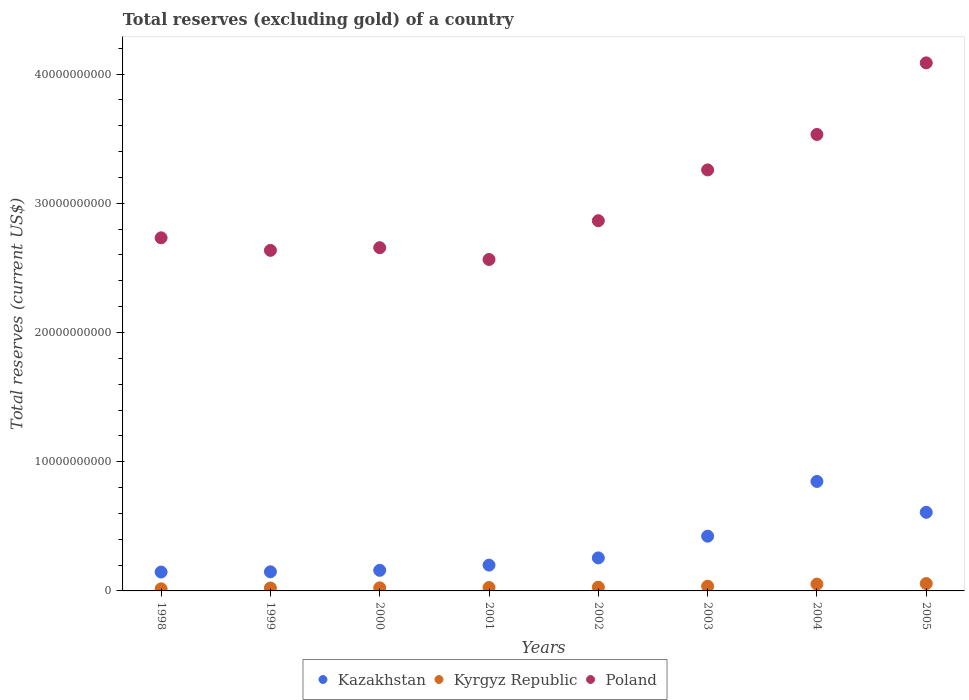How many different coloured dotlines are there?
Make the answer very short. 3. What is the total reserves (excluding gold) in Kazakhstan in 2001?
Ensure brevity in your answer.  2.00e+09. Across all years, what is the maximum total reserves (excluding gold) in Kazakhstan?
Ensure brevity in your answer.  8.47e+09. Across all years, what is the minimum total reserves (excluding gold) in Poland?
Make the answer very short. 2.56e+1. In which year was the total reserves (excluding gold) in Kazakhstan minimum?
Your response must be concise. 1998. What is the total total reserves (excluding gold) in Kyrgyz Republic in the graph?
Provide a short and direct response. 2.65e+09. What is the difference between the total reserves (excluding gold) in Kazakhstan in 2004 and that in 2005?
Offer a terse response. 2.39e+09. What is the difference between the total reserves (excluding gold) in Kazakhstan in 2005 and the total reserves (excluding gold) in Kyrgyz Republic in 2000?
Your answer should be very brief. 5.85e+09. What is the average total reserves (excluding gold) in Kazakhstan per year?
Ensure brevity in your answer.  3.49e+09. In the year 2004, what is the difference between the total reserves (excluding gold) in Kazakhstan and total reserves (excluding gold) in Poland?
Offer a terse response. -2.69e+1. In how many years, is the total reserves (excluding gold) in Poland greater than 24000000000 US$?
Ensure brevity in your answer.  8. What is the ratio of the total reserves (excluding gold) in Kazakhstan in 2000 to that in 2004?
Keep it short and to the point. 0.19. Is the difference between the total reserves (excluding gold) in Kazakhstan in 1998 and 1999 greater than the difference between the total reserves (excluding gold) in Poland in 1998 and 1999?
Provide a succinct answer. No. What is the difference between the highest and the second highest total reserves (excluding gold) in Poland?
Offer a terse response. 5.54e+09. What is the difference between the highest and the lowest total reserves (excluding gold) in Kyrgyz Republic?
Your answer should be very brief. 4.06e+08. Is it the case that in every year, the sum of the total reserves (excluding gold) in Poland and total reserves (excluding gold) in Kazakhstan  is greater than the total reserves (excluding gold) in Kyrgyz Republic?
Provide a short and direct response. Yes. Is the total reserves (excluding gold) in Kazakhstan strictly greater than the total reserves (excluding gold) in Poland over the years?
Your answer should be compact. No. How many dotlines are there?
Provide a succinct answer. 3. How many years are there in the graph?
Provide a short and direct response. 8. Are the values on the major ticks of Y-axis written in scientific E-notation?
Provide a succinct answer. No. Does the graph contain any zero values?
Provide a short and direct response. No. Does the graph contain grids?
Give a very brief answer. No. Where does the legend appear in the graph?
Your response must be concise. Bottom center. What is the title of the graph?
Provide a succinct answer. Total reserves (excluding gold) of a country. Does "Cayman Islands" appear as one of the legend labels in the graph?
Make the answer very short. No. What is the label or title of the X-axis?
Make the answer very short. Years. What is the label or title of the Y-axis?
Your answer should be very brief. Total reserves (current US$). What is the Total reserves (current US$) in Kazakhstan in 1998?
Offer a terse response. 1.46e+09. What is the Total reserves (current US$) of Kyrgyz Republic in 1998?
Provide a short and direct response. 1.64e+08. What is the Total reserves (current US$) of Poland in 1998?
Your response must be concise. 2.73e+1. What is the Total reserves (current US$) of Kazakhstan in 1999?
Provide a short and direct response. 1.48e+09. What is the Total reserves (current US$) in Kyrgyz Republic in 1999?
Your response must be concise. 2.30e+08. What is the Total reserves (current US$) in Poland in 1999?
Offer a very short reply. 2.64e+1. What is the Total reserves (current US$) in Kazakhstan in 2000?
Make the answer very short. 1.59e+09. What is the Total reserves (current US$) of Kyrgyz Republic in 2000?
Provide a succinct answer. 2.39e+08. What is the Total reserves (current US$) in Poland in 2000?
Your answer should be very brief. 2.66e+1. What is the Total reserves (current US$) of Kazakhstan in 2001?
Your answer should be compact. 2.00e+09. What is the Total reserves (current US$) of Kyrgyz Republic in 2001?
Ensure brevity in your answer.  2.64e+08. What is the Total reserves (current US$) of Poland in 2001?
Offer a terse response. 2.56e+1. What is the Total reserves (current US$) in Kazakhstan in 2002?
Your response must be concise. 2.56e+09. What is the Total reserves (current US$) of Kyrgyz Republic in 2002?
Make the answer very short. 2.89e+08. What is the Total reserves (current US$) in Poland in 2002?
Ensure brevity in your answer.  2.86e+1. What is the Total reserves (current US$) in Kazakhstan in 2003?
Give a very brief answer. 4.24e+09. What is the Total reserves (current US$) of Kyrgyz Republic in 2003?
Provide a short and direct response. 3.65e+08. What is the Total reserves (current US$) in Poland in 2003?
Give a very brief answer. 3.26e+1. What is the Total reserves (current US$) in Kazakhstan in 2004?
Offer a very short reply. 8.47e+09. What is the Total reserves (current US$) in Kyrgyz Republic in 2004?
Your response must be concise. 5.28e+08. What is the Total reserves (current US$) of Poland in 2004?
Offer a very short reply. 3.53e+1. What is the Total reserves (current US$) in Kazakhstan in 2005?
Your answer should be compact. 6.08e+09. What is the Total reserves (current US$) of Kyrgyz Republic in 2005?
Ensure brevity in your answer.  5.70e+08. What is the Total reserves (current US$) of Poland in 2005?
Give a very brief answer. 4.09e+1. Across all years, what is the maximum Total reserves (current US$) in Kazakhstan?
Your answer should be compact. 8.47e+09. Across all years, what is the maximum Total reserves (current US$) in Kyrgyz Republic?
Your response must be concise. 5.70e+08. Across all years, what is the maximum Total reserves (current US$) in Poland?
Ensure brevity in your answer.  4.09e+1. Across all years, what is the minimum Total reserves (current US$) in Kazakhstan?
Provide a succinct answer. 1.46e+09. Across all years, what is the minimum Total reserves (current US$) in Kyrgyz Republic?
Your answer should be compact. 1.64e+08. Across all years, what is the minimum Total reserves (current US$) of Poland?
Your response must be concise. 2.56e+1. What is the total Total reserves (current US$) in Kazakhstan in the graph?
Provide a succinct answer. 2.79e+1. What is the total Total reserves (current US$) in Kyrgyz Republic in the graph?
Ensure brevity in your answer.  2.65e+09. What is the total Total reserves (current US$) of Poland in the graph?
Provide a succinct answer. 2.43e+11. What is the difference between the Total reserves (current US$) of Kazakhstan in 1998 and that in 1999?
Your answer should be compact. -1.80e+07. What is the difference between the Total reserves (current US$) of Kyrgyz Republic in 1998 and that in 1999?
Keep it short and to the point. -6.59e+07. What is the difference between the Total reserves (current US$) of Poland in 1998 and that in 1999?
Ensure brevity in your answer.  9.70e+08. What is the difference between the Total reserves (current US$) of Kazakhstan in 1998 and that in 2000?
Ensure brevity in your answer.  -1.33e+08. What is the difference between the Total reserves (current US$) of Kyrgyz Republic in 1998 and that in 2000?
Your response must be concise. -7.53e+07. What is the difference between the Total reserves (current US$) of Poland in 1998 and that in 2000?
Your answer should be compact. 7.63e+08. What is the difference between the Total reserves (current US$) in Kazakhstan in 1998 and that in 2001?
Your answer should be compact. -5.36e+08. What is the difference between the Total reserves (current US$) of Kyrgyz Republic in 1998 and that in 2001?
Keep it short and to the point. -9.98e+07. What is the difference between the Total reserves (current US$) in Poland in 1998 and that in 2001?
Offer a terse response. 1.68e+09. What is the difference between the Total reserves (current US$) of Kazakhstan in 1998 and that in 2002?
Your answer should be compact. -1.09e+09. What is the difference between the Total reserves (current US$) in Kyrgyz Republic in 1998 and that in 2002?
Your answer should be compact. -1.25e+08. What is the difference between the Total reserves (current US$) of Poland in 1998 and that in 2002?
Your response must be concise. -1.32e+09. What is the difference between the Total reserves (current US$) of Kazakhstan in 1998 and that in 2003?
Ensure brevity in your answer.  -2.77e+09. What is the difference between the Total reserves (current US$) in Kyrgyz Republic in 1998 and that in 2003?
Offer a very short reply. -2.01e+08. What is the difference between the Total reserves (current US$) in Poland in 1998 and that in 2003?
Keep it short and to the point. -5.25e+09. What is the difference between the Total reserves (current US$) in Kazakhstan in 1998 and that in 2004?
Provide a short and direct response. -7.01e+09. What is the difference between the Total reserves (current US$) of Kyrgyz Republic in 1998 and that in 2004?
Your response must be concise. -3.64e+08. What is the difference between the Total reserves (current US$) of Poland in 1998 and that in 2004?
Provide a succinct answer. -8.00e+09. What is the difference between the Total reserves (current US$) in Kazakhstan in 1998 and that in 2005?
Your response must be concise. -4.62e+09. What is the difference between the Total reserves (current US$) of Kyrgyz Republic in 1998 and that in 2005?
Ensure brevity in your answer.  -4.06e+08. What is the difference between the Total reserves (current US$) in Poland in 1998 and that in 2005?
Offer a terse response. -1.35e+1. What is the difference between the Total reserves (current US$) of Kazakhstan in 1999 and that in 2000?
Your response must be concise. -1.15e+08. What is the difference between the Total reserves (current US$) of Kyrgyz Republic in 1999 and that in 2000?
Offer a terse response. -9.36e+06. What is the difference between the Total reserves (current US$) of Poland in 1999 and that in 2000?
Make the answer very short. -2.07e+08. What is the difference between the Total reserves (current US$) in Kazakhstan in 1999 and that in 2001?
Your response must be concise. -5.18e+08. What is the difference between the Total reserves (current US$) of Kyrgyz Republic in 1999 and that in 2001?
Your response must be concise. -3.38e+07. What is the difference between the Total reserves (current US$) in Poland in 1999 and that in 2001?
Your response must be concise. 7.06e+08. What is the difference between the Total reserves (current US$) of Kazakhstan in 1999 and that in 2002?
Keep it short and to the point. -1.08e+09. What is the difference between the Total reserves (current US$) of Kyrgyz Republic in 1999 and that in 2002?
Offer a very short reply. -5.92e+07. What is the difference between the Total reserves (current US$) of Poland in 1999 and that in 2002?
Your response must be concise. -2.30e+09. What is the difference between the Total reserves (current US$) of Kazakhstan in 1999 and that in 2003?
Offer a very short reply. -2.76e+09. What is the difference between the Total reserves (current US$) of Kyrgyz Republic in 1999 and that in 2003?
Give a very brief answer. -1.35e+08. What is the difference between the Total reserves (current US$) in Poland in 1999 and that in 2003?
Make the answer very short. -6.22e+09. What is the difference between the Total reserves (current US$) in Kazakhstan in 1999 and that in 2004?
Make the answer very short. -6.99e+09. What is the difference between the Total reserves (current US$) in Kyrgyz Republic in 1999 and that in 2004?
Your response must be concise. -2.98e+08. What is the difference between the Total reserves (current US$) in Poland in 1999 and that in 2004?
Offer a terse response. -8.97e+09. What is the difference between the Total reserves (current US$) in Kazakhstan in 1999 and that in 2005?
Ensure brevity in your answer.  -4.60e+09. What is the difference between the Total reserves (current US$) in Kyrgyz Republic in 1999 and that in 2005?
Make the answer very short. -3.40e+08. What is the difference between the Total reserves (current US$) in Poland in 1999 and that in 2005?
Provide a short and direct response. -1.45e+1. What is the difference between the Total reserves (current US$) in Kazakhstan in 2000 and that in 2001?
Give a very brief answer. -4.03e+08. What is the difference between the Total reserves (current US$) of Kyrgyz Republic in 2000 and that in 2001?
Your response must be concise. -2.45e+07. What is the difference between the Total reserves (current US$) in Poland in 2000 and that in 2001?
Offer a very short reply. 9.14e+08. What is the difference between the Total reserves (current US$) of Kazakhstan in 2000 and that in 2002?
Offer a very short reply. -9.61e+08. What is the difference between the Total reserves (current US$) in Kyrgyz Republic in 2000 and that in 2002?
Ensure brevity in your answer.  -4.98e+07. What is the difference between the Total reserves (current US$) in Poland in 2000 and that in 2002?
Give a very brief answer. -2.09e+09. What is the difference between the Total reserves (current US$) of Kazakhstan in 2000 and that in 2003?
Your answer should be compact. -2.64e+09. What is the difference between the Total reserves (current US$) of Kyrgyz Republic in 2000 and that in 2003?
Offer a terse response. -1.26e+08. What is the difference between the Total reserves (current US$) in Poland in 2000 and that in 2003?
Provide a succinct answer. -6.02e+09. What is the difference between the Total reserves (current US$) in Kazakhstan in 2000 and that in 2004?
Your response must be concise. -6.88e+09. What is the difference between the Total reserves (current US$) in Kyrgyz Republic in 2000 and that in 2004?
Provide a succinct answer. -2.89e+08. What is the difference between the Total reserves (current US$) of Poland in 2000 and that in 2004?
Offer a very short reply. -8.76e+09. What is the difference between the Total reserves (current US$) in Kazakhstan in 2000 and that in 2005?
Offer a very short reply. -4.49e+09. What is the difference between the Total reserves (current US$) of Kyrgyz Republic in 2000 and that in 2005?
Offer a very short reply. -3.31e+08. What is the difference between the Total reserves (current US$) of Poland in 2000 and that in 2005?
Offer a terse response. -1.43e+1. What is the difference between the Total reserves (current US$) in Kazakhstan in 2001 and that in 2002?
Your answer should be compact. -5.58e+08. What is the difference between the Total reserves (current US$) of Kyrgyz Republic in 2001 and that in 2002?
Your response must be concise. -2.53e+07. What is the difference between the Total reserves (current US$) in Poland in 2001 and that in 2002?
Offer a very short reply. -3.00e+09. What is the difference between the Total reserves (current US$) of Kazakhstan in 2001 and that in 2003?
Offer a terse response. -2.24e+09. What is the difference between the Total reserves (current US$) of Kyrgyz Republic in 2001 and that in 2003?
Your answer should be compact. -1.01e+08. What is the difference between the Total reserves (current US$) of Poland in 2001 and that in 2003?
Keep it short and to the point. -6.93e+09. What is the difference between the Total reserves (current US$) of Kazakhstan in 2001 and that in 2004?
Your answer should be compact. -6.48e+09. What is the difference between the Total reserves (current US$) of Kyrgyz Republic in 2001 and that in 2004?
Provide a short and direct response. -2.65e+08. What is the difference between the Total reserves (current US$) in Poland in 2001 and that in 2004?
Give a very brief answer. -9.68e+09. What is the difference between the Total reserves (current US$) in Kazakhstan in 2001 and that in 2005?
Make the answer very short. -4.09e+09. What is the difference between the Total reserves (current US$) of Kyrgyz Republic in 2001 and that in 2005?
Keep it short and to the point. -3.06e+08. What is the difference between the Total reserves (current US$) in Poland in 2001 and that in 2005?
Your answer should be very brief. -1.52e+1. What is the difference between the Total reserves (current US$) in Kazakhstan in 2002 and that in 2003?
Offer a very short reply. -1.68e+09. What is the difference between the Total reserves (current US$) in Kyrgyz Republic in 2002 and that in 2003?
Provide a succinct answer. -7.57e+07. What is the difference between the Total reserves (current US$) in Poland in 2002 and that in 2003?
Offer a terse response. -3.93e+09. What is the difference between the Total reserves (current US$) of Kazakhstan in 2002 and that in 2004?
Make the answer very short. -5.92e+09. What is the difference between the Total reserves (current US$) of Kyrgyz Republic in 2002 and that in 2004?
Make the answer very short. -2.39e+08. What is the difference between the Total reserves (current US$) of Poland in 2002 and that in 2004?
Provide a succinct answer. -6.67e+09. What is the difference between the Total reserves (current US$) in Kazakhstan in 2002 and that in 2005?
Give a very brief answer. -3.53e+09. What is the difference between the Total reserves (current US$) in Kyrgyz Republic in 2002 and that in 2005?
Your answer should be compact. -2.81e+08. What is the difference between the Total reserves (current US$) in Poland in 2002 and that in 2005?
Provide a short and direct response. -1.22e+1. What is the difference between the Total reserves (current US$) of Kazakhstan in 2003 and that in 2004?
Ensure brevity in your answer.  -4.24e+09. What is the difference between the Total reserves (current US$) of Kyrgyz Republic in 2003 and that in 2004?
Keep it short and to the point. -1.64e+08. What is the difference between the Total reserves (current US$) of Poland in 2003 and that in 2004?
Make the answer very short. -2.74e+09. What is the difference between the Total reserves (current US$) of Kazakhstan in 2003 and that in 2005?
Offer a very short reply. -1.85e+09. What is the difference between the Total reserves (current US$) of Kyrgyz Republic in 2003 and that in 2005?
Make the answer very short. -2.05e+08. What is the difference between the Total reserves (current US$) of Poland in 2003 and that in 2005?
Provide a short and direct response. -8.28e+09. What is the difference between the Total reserves (current US$) in Kazakhstan in 2004 and that in 2005?
Your response must be concise. 2.39e+09. What is the difference between the Total reserves (current US$) in Kyrgyz Republic in 2004 and that in 2005?
Provide a succinct answer. -4.16e+07. What is the difference between the Total reserves (current US$) of Poland in 2004 and that in 2005?
Provide a succinct answer. -5.54e+09. What is the difference between the Total reserves (current US$) of Kazakhstan in 1998 and the Total reserves (current US$) of Kyrgyz Republic in 1999?
Your answer should be very brief. 1.23e+09. What is the difference between the Total reserves (current US$) in Kazakhstan in 1998 and the Total reserves (current US$) in Poland in 1999?
Ensure brevity in your answer.  -2.49e+1. What is the difference between the Total reserves (current US$) in Kyrgyz Republic in 1998 and the Total reserves (current US$) in Poland in 1999?
Your answer should be very brief. -2.62e+1. What is the difference between the Total reserves (current US$) in Kazakhstan in 1998 and the Total reserves (current US$) in Kyrgyz Republic in 2000?
Give a very brief answer. 1.22e+09. What is the difference between the Total reserves (current US$) in Kazakhstan in 1998 and the Total reserves (current US$) in Poland in 2000?
Your answer should be very brief. -2.51e+1. What is the difference between the Total reserves (current US$) of Kyrgyz Republic in 1998 and the Total reserves (current US$) of Poland in 2000?
Give a very brief answer. -2.64e+1. What is the difference between the Total reserves (current US$) of Kazakhstan in 1998 and the Total reserves (current US$) of Kyrgyz Republic in 2001?
Provide a succinct answer. 1.20e+09. What is the difference between the Total reserves (current US$) of Kazakhstan in 1998 and the Total reserves (current US$) of Poland in 2001?
Provide a succinct answer. -2.42e+1. What is the difference between the Total reserves (current US$) in Kyrgyz Republic in 1998 and the Total reserves (current US$) in Poland in 2001?
Provide a succinct answer. -2.55e+1. What is the difference between the Total reserves (current US$) of Kazakhstan in 1998 and the Total reserves (current US$) of Kyrgyz Republic in 2002?
Your answer should be very brief. 1.17e+09. What is the difference between the Total reserves (current US$) of Kazakhstan in 1998 and the Total reserves (current US$) of Poland in 2002?
Your answer should be compact. -2.72e+1. What is the difference between the Total reserves (current US$) of Kyrgyz Republic in 1998 and the Total reserves (current US$) of Poland in 2002?
Ensure brevity in your answer.  -2.85e+1. What is the difference between the Total reserves (current US$) in Kazakhstan in 1998 and the Total reserves (current US$) in Kyrgyz Republic in 2003?
Your answer should be compact. 1.10e+09. What is the difference between the Total reserves (current US$) of Kazakhstan in 1998 and the Total reserves (current US$) of Poland in 2003?
Provide a short and direct response. -3.11e+1. What is the difference between the Total reserves (current US$) in Kyrgyz Republic in 1998 and the Total reserves (current US$) in Poland in 2003?
Keep it short and to the point. -3.24e+1. What is the difference between the Total reserves (current US$) in Kazakhstan in 1998 and the Total reserves (current US$) in Kyrgyz Republic in 2004?
Offer a terse response. 9.33e+08. What is the difference between the Total reserves (current US$) of Kazakhstan in 1998 and the Total reserves (current US$) of Poland in 2004?
Give a very brief answer. -3.39e+1. What is the difference between the Total reserves (current US$) of Kyrgyz Republic in 1998 and the Total reserves (current US$) of Poland in 2004?
Your answer should be compact. -3.52e+1. What is the difference between the Total reserves (current US$) in Kazakhstan in 1998 and the Total reserves (current US$) in Kyrgyz Republic in 2005?
Your answer should be very brief. 8.91e+08. What is the difference between the Total reserves (current US$) of Kazakhstan in 1998 and the Total reserves (current US$) of Poland in 2005?
Make the answer very short. -3.94e+1. What is the difference between the Total reserves (current US$) in Kyrgyz Republic in 1998 and the Total reserves (current US$) in Poland in 2005?
Your response must be concise. -4.07e+1. What is the difference between the Total reserves (current US$) in Kazakhstan in 1999 and the Total reserves (current US$) in Kyrgyz Republic in 2000?
Keep it short and to the point. 1.24e+09. What is the difference between the Total reserves (current US$) of Kazakhstan in 1999 and the Total reserves (current US$) of Poland in 2000?
Make the answer very short. -2.51e+1. What is the difference between the Total reserves (current US$) in Kyrgyz Republic in 1999 and the Total reserves (current US$) in Poland in 2000?
Provide a short and direct response. -2.63e+1. What is the difference between the Total reserves (current US$) in Kazakhstan in 1999 and the Total reserves (current US$) in Kyrgyz Republic in 2001?
Provide a short and direct response. 1.22e+09. What is the difference between the Total reserves (current US$) of Kazakhstan in 1999 and the Total reserves (current US$) of Poland in 2001?
Give a very brief answer. -2.42e+1. What is the difference between the Total reserves (current US$) in Kyrgyz Republic in 1999 and the Total reserves (current US$) in Poland in 2001?
Your answer should be compact. -2.54e+1. What is the difference between the Total reserves (current US$) of Kazakhstan in 1999 and the Total reserves (current US$) of Kyrgyz Republic in 2002?
Give a very brief answer. 1.19e+09. What is the difference between the Total reserves (current US$) in Kazakhstan in 1999 and the Total reserves (current US$) in Poland in 2002?
Make the answer very short. -2.72e+1. What is the difference between the Total reserves (current US$) of Kyrgyz Republic in 1999 and the Total reserves (current US$) of Poland in 2002?
Your answer should be very brief. -2.84e+1. What is the difference between the Total reserves (current US$) of Kazakhstan in 1999 and the Total reserves (current US$) of Kyrgyz Republic in 2003?
Give a very brief answer. 1.11e+09. What is the difference between the Total reserves (current US$) of Kazakhstan in 1999 and the Total reserves (current US$) of Poland in 2003?
Offer a very short reply. -3.11e+1. What is the difference between the Total reserves (current US$) in Kyrgyz Republic in 1999 and the Total reserves (current US$) in Poland in 2003?
Your answer should be compact. -3.23e+1. What is the difference between the Total reserves (current US$) in Kazakhstan in 1999 and the Total reserves (current US$) in Kyrgyz Republic in 2004?
Ensure brevity in your answer.  9.51e+08. What is the difference between the Total reserves (current US$) in Kazakhstan in 1999 and the Total reserves (current US$) in Poland in 2004?
Your response must be concise. -3.38e+1. What is the difference between the Total reserves (current US$) in Kyrgyz Republic in 1999 and the Total reserves (current US$) in Poland in 2004?
Provide a short and direct response. -3.51e+1. What is the difference between the Total reserves (current US$) in Kazakhstan in 1999 and the Total reserves (current US$) in Kyrgyz Republic in 2005?
Your answer should be compact. 9.10e+08. What is the difference between the Total reserves (current US$) in Kazakhstan in 1999 and the Total reserves (current US$) in Poland in 2005?
Make the answer very short. -3.94e+1. What is the difference between the Total reserves (current US$) in Kyrgyz Republic in 1999 and the Total reserves (current US$) in Poland in 2005?
Make the answer very short. -4.06e+1. What is the difference between the Total reserves (current US$) of Kazakhstan in 2000 and the Total reserves (current US$) of Kyrgyz Republic in 2001?
Provide a short and direct response. 1.33e+09. What is the difference between the Total reserves (current US$) of Kazakhstan in 2000 and the Total reserves (current US$) of Poland in 2001?
Your answer should be compact. -2.41e+1. What is the difference between the Total reserves (current US$) of Kyrgyz Republic in 2000 and the Total reserves (current US$) of Poland in 2001?
Give a very brief answer. -2.54e+1. What is the difference between the Total reserves (current US$) in Kazakhstan in 2000 and the Total reserves (current US$) in Kyrgyz Republic in 2002?
Your response must be concise. 1.31e+09. What is the difference between the Total reserves (current US$) in Kazakhstan in 2000 and the Total reserves (current US$) in Poland in 2002?
Provide a succinct answer. -2.71e+1. What is the difference between the Total reserves (current US$) of Kyrgyz Republic in 2000 and the Total reserves (current US$) of Poland in 2002?
Make the answer very short. -2.84e+1. What is the difference between the Total reserves (current US$) of Kazakhstan in 2000 and the Total reserves (current US$) of Kyrgyz Republic in 2003?
Your answer should be very brief. 1.23e+09. What is the difference between the Total reserves (current US$) in Kazakhstan in 2000 and the Total reserves (current US$) in Poland in 2003?
Your answer should be very brief. -3.10e+1. What is the difference between the Total reserves (current US$) of Kyrgyz Republic in 2000 and the Total reserves (current US$) of Poland in 2003?
Offer a terse response. -3.23e+1. What is the difference between the Total reserves (current US$) of Kazakhstan in 2000 and the Total reserves (current US$) of Kyrgyz Republic in 2004?
Your answer should be compact. 1.07e+09. What is the difference between the Total reserves (current US$) of Kazakhstan in 2000 and the Total reserves (current US$) of Poland in 2004?
Give a very brief answer. -3.37e+1. What is the difference between the Total reserves (current US$) in Kyrgyz Republic in 2000 and the Total reserves (current US$) in Poland in 2004?
Make the answer very short. -3.51e+1. What is the difference between the Total reserves (current US$) in Kazakhstan in 2000 and the Total reserves (current US$) in Kyrgyz Republic in 2005?
Ensure brevity in your answer.  1.02e+09. What is the difference between the Total reserves (current US$) of Kazakhstan in 2000 and the Total reserves (current US$) of Poland in 2005?
Offer a very short reply. -3.93e+1. What is the difference between the Total reserves (current US$) in Kyrgyz Republic in 2000 and the Total reserves (current US$) in Poland in 2005?
Provide a succinct answer. -4.06e+1. What is the difference between the Total reserves (current US$) of Kazakhstan in 2001 and the Total reserves (current US$) of Kyrgyz Republic in 2002?
Offer a very short reply. 1.71e+09. What is the difference between the Total reserves (current US$) of Kazakhstan in 2001 and the Total reserves (current US$) of Poland in 2002?
Your answer should be very brief. -2.67e+1. What is the difference between the Total reserves (current US$) of Kyrgyz Republic in 2001 and the Total reserves (current US$) of Poland in 2002?
Offer a very short reply. -2.84e+1. What is the difference between the Total reserves (current US$) in Kazakhstan in 2001 and the Total reserves (current US$) in Kyrgyz Republic in 2003?
Offer a very short reply. 1.63e+09. What is the difference between the Total reserves (current US$) in Kazakhstan in 2001 and the Total reserves (current US$) in Poland in 2003?
Make the answer very short. -3.06e+1. What is the difference between the Total reserves (current US$) of Kyrgyz Republic in 2001 and the Total reserves (current US$) of Poland in 2003?
Offer a terse response. -3.23e+1. What is the difference between the Total reserves (current US$) in Kazakhstan in 2001 and the Total reserves (current US$) in Kyrgyz Republic in 2004?
Make the answer very short. 1.47e+09. What is the difference between the Total reserves (current US$) in Kazakhstan in 2001 and the Total reserves (current US$) in Poland in 2004?
Your response must be concise. -3.33e+1. What is the difference between the Total reserves (current US$) of Kyrgyz Republic in 2001 and the Total reserves (current US$) of Poland in 2004?
Keep it short and to the point. -3.51e+1. What is the difference between the Total reserves (current US$) in Kazakhstan in 2001 and the Total reserves (current US$) in Kyrgyz Republic in 2005?
Offer a very short reply. 1.43e+09. What is the difference between the Total reserves (current US$) in Kazakhstan in 2001 and the Total reserves (current US$) in Poland in 2005?
Ensure brevity in your answer.  -3.89e+1. What is the difference between the Total reserves (current US$) of Kyrgyz Republic in 2001 and the Total reserves (current US$) of Poland in 2005?
Offer a very short reply. -4.06e+1. What is the difference between the Total reserves (current US$) in Kazakhstan in 2002 and the Total reserves (current US$) in Kyrgyz Republic in 2003?
Your response must be concise. 2.19e+09. What is the difference between the Total reserves (current US$) in Kazakhstan in 2002 and the Total reserves (current US$) in Poland in 2003?
Make the answer very short. -3.00e+1. What is the difference between the Total reserves (current US$) of Kyrgyz Republic in 2002 and the Total reserves (current US$) of Poland in 2003?
Ensure brevity in your answer.  -3.23e+1. What is the difference between the Total reserves (current US$) of Kazakhstan in 2002 and the Total reserves (current US$) of Kyrgyz Republic in 2004?
Make the answer very short. 2.03e+09. What is the difference between the Total reserves (current US$) of Kazakhstan in 2002 and the Total reserves (current US$) of Poland in 2004?
Provide a succinct answer. -3.28e+1. What is the difference between the Total reserves (current US$) in Kyrgyz Republic in 2002 and the Total reserves (current US$) in Poland in 2004?
Make the answer very short. -3.50e+1. What is the difference between the Total reserves (current US$) in Kazakhstan in 2002 and the Total reserves (current US$) in Kyrgyz Republic in 2005?
Provide a succinct answer. 1.99e+09. What is the difference between the Total reserves (current US$) in Kazakhstan in 2002 and the Total reserves (current US$) in Poland in 2005?
Provide a short and direct response. -3.83e+1. What is the difference between the Total reserves (current US$) in Kyrgyz Republic in 2002 and the Total reserves (current US$) in Poland in 2005?
Your response must be concise. -4.06e+1. What is the difference between the Total reserves (current US$) in Kazakhstan in 2003 and the Total reserves (current US$) in Kyrgyz Republic in 2004?
Give a very brief answer. 3.71e+09. What is the difference between the Total reserves (current US$) in Kazakhstan in 2003 and the Total reserves (current US$) in Poland in 2004?
Your answer should be very brief. -3.11e+1. What is the difference between the Total reserves (current US$) of Kyrgyz Republic in 2003 and the Total reserves (current US$) of Poland in 2004?
Ensure brevity in your answer.  -3.50e+1. What is the difference between the Total reserves (current US$) in Kazakhstan in 2003 and the Total reserves (current US$) in Kyrgyz Republic in 2005?
Your answer should be very brief. 3.67e+09. What is the difference between the Total reserves (current US$) of Kazakhstan in 2003 and the Total reserves (current US$) of Poland in 2005?
Provide a succinct answer. -3.66e+1. What is the difference between the Total reserves (current US$) of Kyrgyz Republic in 2003 and the Total reserves (current US$) of Poland in 2005?
Your answer should be compact. -4.05e+1. What is the difference between the Total reserves (current US$) of Kazakhstan in 2004 and the Total reserves (current US$) of Kyrgyz Republic in 2005?
Offer a terse response. 7.90e+09. What is the difference between the Total reserves (current US$) in Kazakhstan in 2004 and the Total reserves (current US$) in Poland in 2005?
Ensure brevity in your answer.  -3.24e+1. What is the difference between the Total reserves (current US$) in Kyrgyz Republic in 2004 and the Total reserves (current US$) in Poland in 2005?
Your answer should be compact. -4.03e+1. What is the average Total reserves (current US$) of Kazakhstan per year?
Your answer should be very brief. 3.49e+09. What is the average Total reserves (current US$) of Kyrgyz Republic per year?
Keep it short and to the point. 3.31e+08. What is the average Total reserves (current US$) in Poland per year?
Keep it short and to the point. 3.04e+1. In the year 1998, what is the difference between the Total reserves (current US$) in Kazakhstan and Total reserves (current US$) in Kyrgyz Republic?
Ensure brevity in your answer.  1.30e+09. In the year 1998, what is the difference between the Total reserves (current US$) in Kazakhstan and Total reserves (current US$) in Poland?
Offer a terse response. -2.59e+1. In the year 1998, what is the difference between the Total reserves (current US$) in Kyrgyz Republic and Total reserves (current US$) in Poland?
Ensure brevity in your answer.  -2.72e+1. In the year 1999, what is the difference between the Total reserves (current US$) of Kazakhstan and Total reserves (current US$) of Kyrgyz Republic?
Make the answer very short. 1.25e+09. In the year 1999, what is the difference between the Total reserves (current US$) in Kazakhstan and Total reserves (current US$) in Poland?
Your answer should be very brief. -2.49e+1. In the year 1999, what is the difference between the Total reserves (current US$) in Kyrgyz Republic and Total reserves (current US$) in Poland?
Provide a succinct answer. -2.61e+1. In the year 2000, what is the difference between the Total reserves (current US$) in Kazakhstan and Total reserves (current US$) in Kyrgyz Republic?
Your answer should be compact. 1.36e+09. In the year 2000, what is the difference between the Total reserves (current US$) in Kazakhstan and Total reserves (current US$) in Poland?
Ensure brevity in your answer.  -2.50e+1. In the year 2000, what is the difference between the Total reserves (current US$) in Kyrgyz Republic and Total reserves (current US$) in Poland?
Make the answer very short. -2.63e+1. In the year 2001, what is the difference between the Total reserves (current US$) in Kazakhstan and Total reserves (current US$) in Kyrgyz Republic?
Give a very brief answer. 1.73e+09. In the year 2001, what is the difference between the Total reserves (current US$) of Kazakhstan and Total reserves (current US$) of Poland?
Give a very brief answer. -2.37e+1. In the year 2001, what is the difference between the Total reserves (current US$) in Kyrgyz Republic and Total reserves (current US$) in Poland?
Offer a very short reply. -2.54e+1. In the year 2002, what is the difference between the Total reserves (current US$) of Kazakhstan and Total reserves (current US$) of Kyrgyz Republic?
Your answer should be compact. 2.27e+09. In the year 2002, what is the difference between the Total reserves (current US$) in Kazakhstan and Total reserves (current US$) in Poland?
Provide a succinct answer. -2.61e+1. In the year 2002, what is the difference between the Total reserves (current US$) in Kyrgyz Republic and Total reserves (current US$) in Poland?
Offer a terse response. -2.84e+1. In the year 2003, what is the difference between the Total reserves (current US$) in Kazakhstan and Total reserves (current US$) in Kyrgyz Republic?
Provide a succinct answer. 3.87e+09. In the year 2003, what is the difference between the Total reserves (current US$) of Kazakhstan and Total reserves (current US$) of Poland?
Keep it short and to the point. -2.83e+1. In the year 2003, what is the difference between the Total reserves (current US$) in Kyrgyz Republic and Total reserves (current US$) in Poland?
Give a very brief answer. -3.22e+1. In the year 2004, what is the difference between the Total reserves (current US$) in Kazakhstan and Total reserves (current US$) in Kyrgyz Republic?
Keep it short and to the point. 7.94e+09. In the year 2004, what is the difference between the Total reserves (current US$) of Kazakhstan and Total reserves (current US$) of Poland?
Give a very brief answer. -2.69e+1. In the year 2004, what is the difference between the Total reserves (current US$) of Kyrgyz Republic and Total reserves (current US$) of Poland?
Your answer should be compact. -3.48e+1. In the year 2005, what is the difference between the Total reserves (current US$) in Kazakhstan and Total reserves (current US$) in Kyrgyz Republic?
Ensure brevity in your answer.  5.51e+09. In the year 2005, what is the difference between the Total reserves (current US$) of Kazakhstan and Total reserves (current US$) of Poland?
Your answer should be compact. -3.48e+1. In the year 2005, what is the difference between the Total reserves (current US$) in Kyrgyz Republic and Total reserves (current US$) in Poland?
Give a very brief answer. -4.03e+1. What is the ratio of the Total reserves (current US$) in Kazakhstan in 1998 to that in 1999?
Offer a terse response. 0.99. What is the ratio of the Total reserves (current US$) of Kyrgyz Republic in 1998 to that in 1999?
Offer a very short reply. 0.71. What is the ratio of the Total reserves (current US$) of Poland in 1998 to that in 1999?
Your response must be concise. 1.04. What is the ratio of the Total reserves (current US$) of Kazakhstan in 1998 to that in 2000?
Your answer should be compact. 0.92. What is the ratio of the Total reserves (current US$) in Kyrgyz Republic in 1998 to that in 2000?
Offer a terse response. 0.69. What is the ratio of the Total reserves (current US$) in Poland in 1998 to that in 2000?
Provide a succinct answer. 1.03. What is the ratio of the Total reserves (current US$) in Kazakhstan in 1998 to that in 2001?
Your response must be concise. 0.73. What is the ratio of the Total reserves (current US$) of Kyrgyz Republic in 1998 to that in 2001?
Your response must be concise. 0.62. What is the ratio of the Total reserves (current US$) in Poland in 1998 to that in 2001?
Give a very brief answer. 1.07. What is the ratio of the Total reserves (current US$) of Kazakhstan in 1998 to that in 2002?
Provide a succinct answer. 0.57. What is the ratio of the Total reserves (current US$) of Kyrgyz Republic in 1998 to that in 2002?
Keep it short and to the point. 0.57. What is the ratio of the Total reserves (current US$) in Poland in 1998 to that in 2002?
Ensure brevity in your answer.  0.95. What is the ratio of the Total reserves (current US$) of Kazakhstan in 1998 to that in 2003?
Make the answer very short. 0.34. What is the ratio of the Total reserves (current US$) of Kyrgyz Republic in 1998 to that in 2003?
Offer a terse response. 0.45. What is the ratio of the Total reserves (current US$) in Poland in 1998 to that in 2003?
Ensure brevity in your answer.  0.84. What is the ratio of the Total reserves (current US$) of Kazakhstan in 1998 to that in 2004?
Provide a short and direct response. 0.17. What is the ratio of the Total reserves (current US$) in Kyrgyz Republic in 1998 to that in 2004?
Keep it short and to the point. 0.31. What is the ratio of the Total reserves (current US$) of Poland in 1998 to that in 2004?
Offer a very short reply. 0.77. What is the ratio of the Total reserves (current US$) of Kazakhstan in 1998 to that in 2005?
Make the answer very short. 0.24. What is the ratio of the Total reserves (current US$) of Kyrgyz Republic in 1998 to that in 2005?
Offer a terse response. 0.29. What is the ratio of the Total reserves (current US$) in Poland in 1998 to that in 2005?
Provide a short and direct response. 0.67. What is the ratio of the Total reserves (current US$) of Kazakhstan in 1999 to that in 2000?
Give a very brief answer. 0.93. What is the ratio of the Total reserves (current US$) of Kyrgyz Republic in 1999 to that in 2000?
Ensure brevity in your answer.  0.96. What is the ratio of the Total reserves (current US$) of Kazakhstan in 1999 to that in 2001?
Give a very brief answer. 0.74. What is the ratio of the Total reserves (current US$) in Kyrgyz Republic in 1999 to that in 2001?
Ensure brevity in your answer.  0.87. What is the ratio of the Total reserves (current US$) of Poland in 1999 to that in 2001?
Your answer should be very brief. 1.03. What is the ratio of the Total reserves (current US$) in Kazakhstan in 1999 to that in 2002?
Your answer should be compact. 0.58. What is the ratio of the Total reserves (current US$) in Kyrgyz Republic in 1999 to that in 2002?
Your answer should be compact. 0.8. What is the ratio of the Total reserves (current US$) in Poland in 1999 to that in 2002?
Offer a terse response. 0.92. What is the ratio of the Total reserves (current US$) of Kazakhstan in 1999 to that in 2003?
Provide a succinct answer. 0.35. What is the ratio of the Total reserves (current US$) in Kyrgyz Republic in 1999 to that in 2003?
Your response must be concise. 0.63. What is the ratio of the Total reserves (current US$) in Poland in 1999 to that in 2003?
Offer a very short reply. 0.81. What is the ratio of the Total reserves (current US$) in Kazakhstan in 1999 to that in 2004?
Offer a terse response. 0.17. What is the ratio of the Total reserves (current US$) of Kyrgyz Republic in 1999 to that in 2004?
Provide a succinct answer. 0.43. What is the ratio of the Total reserves (current US$) in Poland in 1999 to that in 2004?
Your answer should be compact. 0.75. What is the ratio of the Total reserves (current US$) of Kazakhstan in 1999 to that in 2005?
Provide a short and direct response. 0.24. What is the ratio of the Total reserves (current US$) of Kyrgyz Republic in 1999 to that in 2005?
Give a very brief answer. 0.4. What is the ratio of the Total reserves (current US$) of Poland in 1999 to that in 2005?
Give a very brief answer. 0.64. What is the ratio of the Total reserves (current US$) of Kazakhstan in 2000 to that in 2001?
Your answer should be compact. 0.8. What is the ratio of the Total reserves (current US$) of Kyrgyz Republic in 2000 to that in 2001?
Give a very brief answer. 0.91. What is the ratio of the Total reserves (current US$) of Poland in 2000 to that in 2001?
Offer a terse response. 1.04. What is the ratio of the Total reserves (current US$) of Kazakhstan in 2000 to that in 2002?
Ensure brevity in your answer.  0.62. What is the ratio of the Total reserves (current US$) of Kyrgyz Republic in 2000 to that in 2002?
Your answer should be compact. 0.83. What is the ratio of the Total reserves (current US$) in Poland in 2000 to that in 2002?
Offer a very short reply. 0.93. What is the ratio of the Total reserves (current US$) in Kazakhstan in 2000 to that in 2003?
Provide a short and direct response. 0.38. What is the ratio of the Total reserves (current US$) in Kyrgyz Republic in 2000 to that in 2003?
Offer a terse response. 0.66. What is the ratio of the Total reserves (current US$) in Poland in 2000 to that in 2003?
Your answer should be compact. 0.82. What is the ratio of the Total reserves (current US$) of Kazakhstan in 2000 to that in 2004?
Your answer should be very brief. 0.19. What is the ratio of the Total reserves (current US$) in Kyrgyz Republic in 2000 to that in 2004?
Give a very brief answer. 0.45. What is the ratio of the Total reserves (current US$) in Poland in 2000 to that in 2004?
Your response must be concise. 0.75. What is the ratio of the Total reserves (current US$) of Kazakhstan in 2000 to that in 2005?
Provide a succinct answer. 0.26. What is the ratio of the Total reserves (current US$) of Kyrgyz Republic in 2000 to that in 2005?
Your answer should be very brief. 0.42. What is the ratio of the Total reserves (current US$) of Poland in 2000 to that in 2005?
Ensure brevity in your answer.  0.65. What is the ratio of the Total reserves (current US$) of Kazakhstan in 2001 to that in 2002?
Offer a terse response. 0.78. What is the ratio of the Total reserves (current US$) in Kyrgyz Republic in 2001 to that in 2002?
Offer a very short reply. 0.91. What is the ratio of the Total reserves (current US$) of Poland in 2001 to that in 2002?
Provide a short and direct response. 0.9. What is the ratio of the Total reserves (current US$) of Kazakhstan in 2001 to that in 2003?
Your response must be concise. 0.47. What is the ratio of the Total reserves (current US$) in Kyrgyz Republic in 2001 to that in 2003?
Provide a succinct answer. 0.72. What is the ratio of the Total reserves (current US$) of Poland in 2001 to that in 2003?
Your answer should be very brief. 0.79. What is the ratio of the Total reserves (current US$) in Kazakhstan in 2001 to that in 2004?
Your response must be concise. 0.24. What is the ratio of the Total reserves (current US$) in Kyrgyz Republic in 2001 to that in 2004?
Your answer should be compact. 0.5. What is the ratio of the Total reserves (current US$) of Poland in 2001 to that in 2004?
Your response must be concise. 0.73. What is the ratio of the Total reserves (current US$) in Kazakhstan in 2001 to that in 2005?
Your response must be concise. 0.33. What is the ratio of the Total reserves (current US$) in Kyrgyz Republic in 2001 to that in 2005?
Make the answer very short. 0.46. What is the ratio of the Total reserves (current US$) in Poland in 2001 to that in 2005?
Your response must be concise. 0.63. What is the ratio of the Total reserves (current US$) of Kazakhstan in 2002 to that in 2003?
Your answer should be very brief. 0.6. What is the ratio of the Total reserves (current US$) of Kyrgyz Republic in 2002 to that in 2003?
Keep it short and to the point. 0.79. What is the ratio of the Total reserves (current US$) of Poland in 2002 to that in 2003?
Give a very brief answer. 0.88. What is the ratio of the Total reserves (current US$) of Kazakhstan in 2002 to that in 2004?
Give a very brief answer. 0.3. What is the ratio of the Total reserves (current US$) of Kyrgyz Republic in 2002 to that in 2004?
Your response must be concise. 0.55. What is the ratio of the Total reserves (current US$) in Poland in 2002 to that in 2004?
Provide a short and direct response. 0.81. What is the ratio of the Total reserves (current US$) in Kazakhstan in 2002 to that in 2005?
Offer a very short reply. 0.42. What is the ratio of the Total reserves (current US$) of Kyrgyz Republic in 2002 to that in 2005?
Your response must be concise. 0.51. What is the ratio of the Total reserves (current US$) in Poland in 2002 to that in 2005?
Keep it short and to the point. 0.7. What is the ratio of the Total reserves (current US$) of Kyrgyz Republic in 2003 to that in 2004?
Your answer should be compact. 0.69. What is the ratio of the Total reserves (current US$) in Poland in 2003 to that in 2004?
Give a very brief answer. 0.92. What is the ratio of the Total reserves (current US$) in Kazakhstan in 2003 to that in 2005?
Keep it short and to the point. 0.7. What is the ratio of the Total reserves (current US$) in Kyrgyz Republic in 2003 to that in 2005?
Provide a short and direct response. 0.64. What is the ratio of the Total reserves (current US$) in Poland in 2003 to that in 2005?
Make the answer very short. 0.8. What is the ratio of the Total reserves (current US$) of Kazakhstan in 2004 to that in 2005?
Provide a succinct answer. 1.39. What is the ratio of the Total reserves (current US$) of Kyrgyz Republic in 2004 to that in 2005?
Give a very brief answer. 0.93. What is the ratio of the Total reserves (current US$) in Poland in 2004 to that in 2005?
Provide a short and direct response. 0.86. What is the difference between the highest and the second highest Total reserves (current US$) in Kazakhstan?
Your answer should be very brief. 2.39e+09. What is the difference between the highest and the second highest Total reserves (current US$) of Kyrgyz Republic?
Ensure brevity in your answer.  4.16e+07. What is the difference between the highest and the second highest Total reserves (current US$) in Poland?
Provide a short and direct response. 5.54e+09. What is the difference between the highest and the lowest Total reserves (current US$) of Kazakhstan?
Offer a terse response. 7.01e+09. What is the difference between the highest and the lowest Total reserves (current US$) of Kyrgyz Republic?
Give a very brief answer. 4.06e+08. What is the difference between the highest and the lowest Total reserves (current US$) in Poland?
Provide a short and direct response. 1.52e+1. 